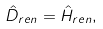<formula> <loc_0><loc_0><loc_500><loc_500>\hat { D } _ { r e n } = \hat { H } _ { r e n } ,</formula> 